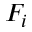<formula> <loc_0><loc_0><loc_500><loc_500>F _ { i }</formula> 